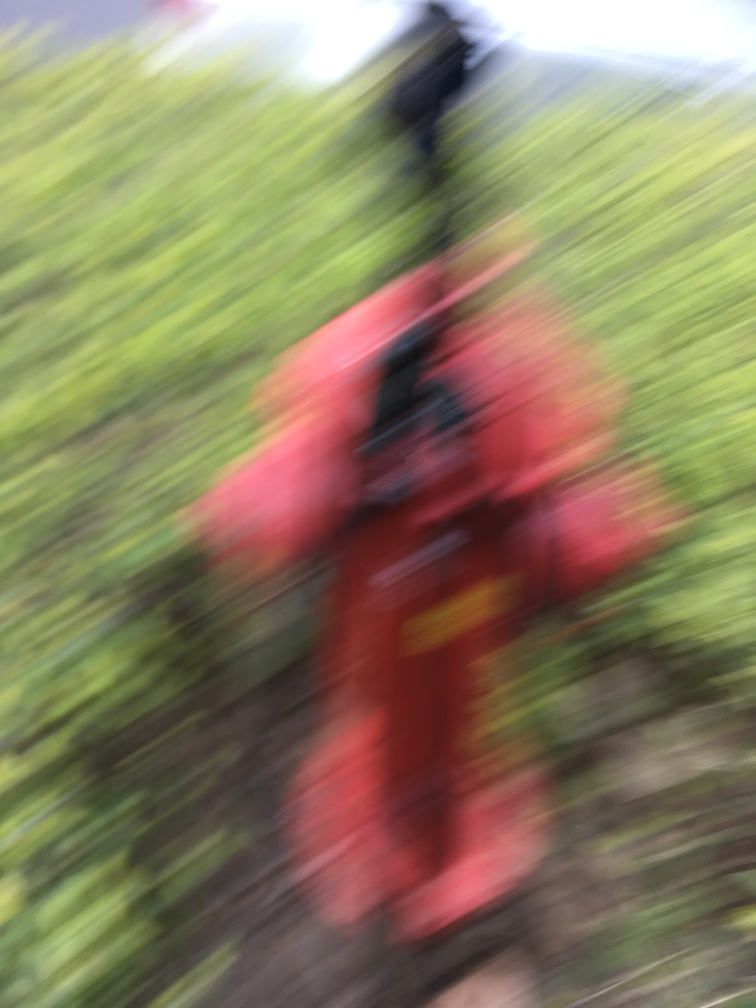Are there any quality issues with this image? Yes, there are quality issues with this image. It appears to be significantly blurred, resulting in a lack of clear detail and making it difficult to discern specific features or subjects within the photo. 